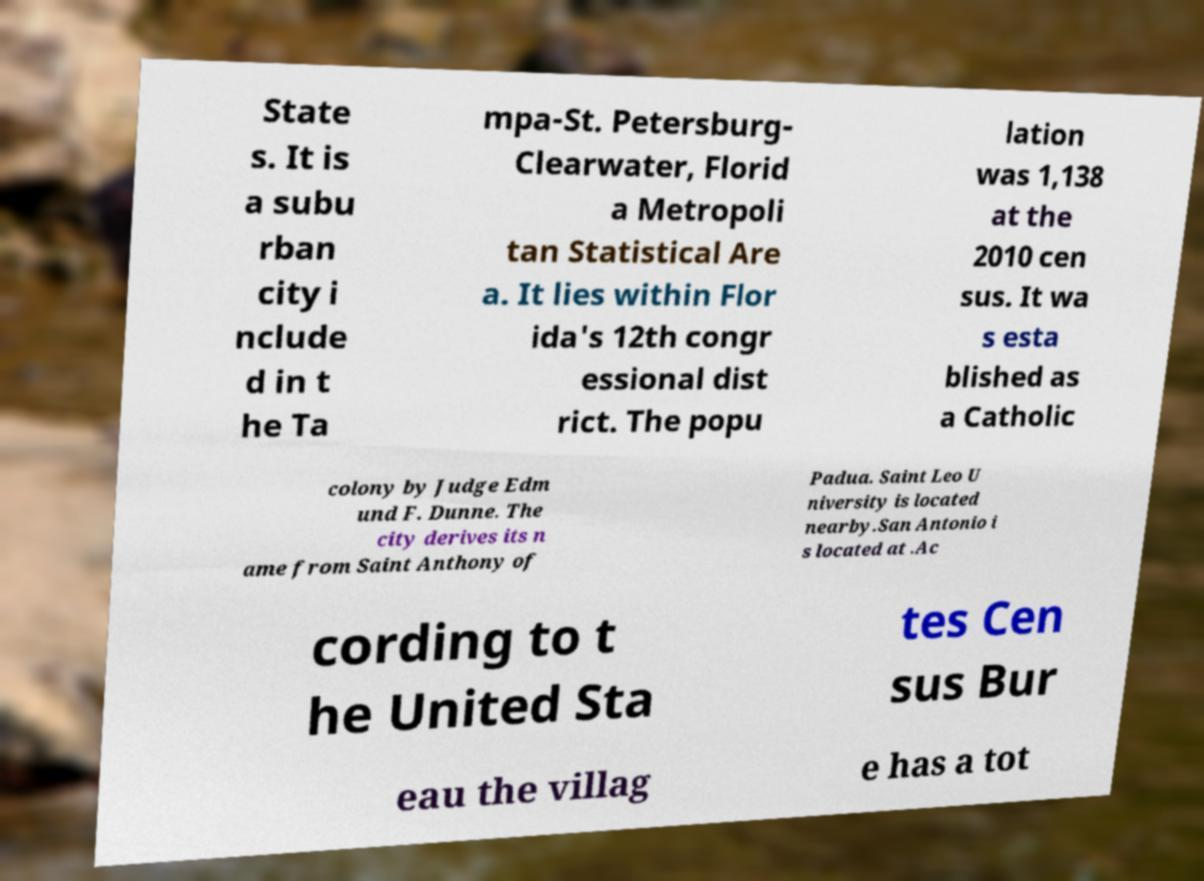For documentation purposes, I need the text within this image transcribed. Could you provide that? State s. It is a subu rban city i nclude d in t he Ta mpa-St. Petersburg- Clearwater, Florid a Metropoli tan Statistical Are a. It lies within Flor ida's 12th congr essional dist rict. The popu lation was 1,138 at the 2010 cen sus. It wa s esta blished as a Catholic colony by Judge Edm und F. Dunne. The city derives its n ame from Saint Anthony of Padua. Saint Leo U niversity is located nearby.San Antonio i s located at .Ac cording to t he United Sta tes Cen sus Bur eau the villag e has a tot 